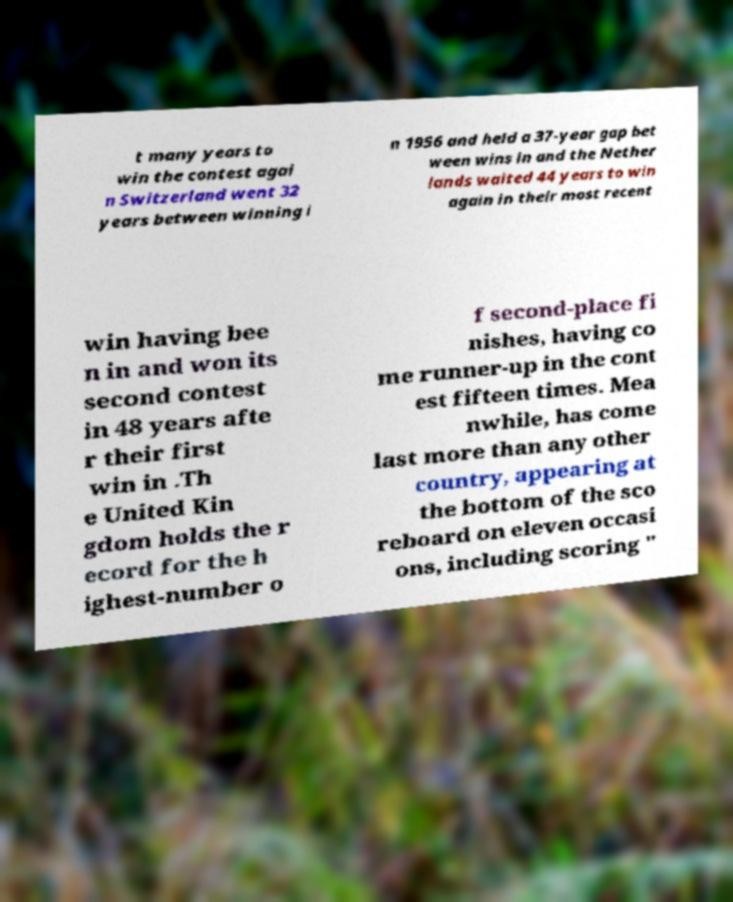Please identify and transcribe the text found in this image. t many years to win the contest agai n Switzerland went 32 years between winning i n 1956 and held a 37-year gap bet ween wins in and the Nether lands waited 44 years to win again in their most recent win having bee n in and won its second contest in 48 years afte r their first win in .Th e United Kin gdom holds the r ecord for the h ighest-number o f second-place fi nishes, having co me runner-up in the cont est fifteen times. Mea nwhile, has come last more than any other country, appearing at the bottom of the sco reboard on eleven occasi ons, including scoring " 